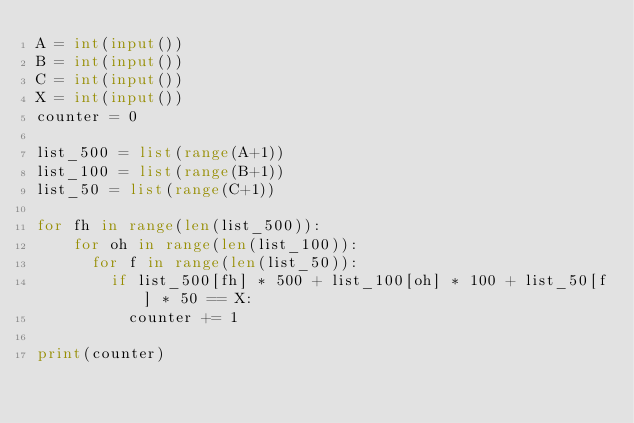Convert code to text. <code><loc_0><loc_0><loc_500><loc_500><_Python_>A = int(input())
B = int(input())
C = int(input())
X = int(input())
counter = 0

list_500 = list(range(A+1))
list_100 = list(range(B+1))
list_50 = list(range(C+1))

for fh in range(len(list_500)):
    for oh in range(len(list_100)):
      for f in range(len(list_50)):
        if list_500[fh] * 500 + list_100[oh] * 100 + list_50[f] * 50 == X:
          counter += 1

print(counter)
</code> 